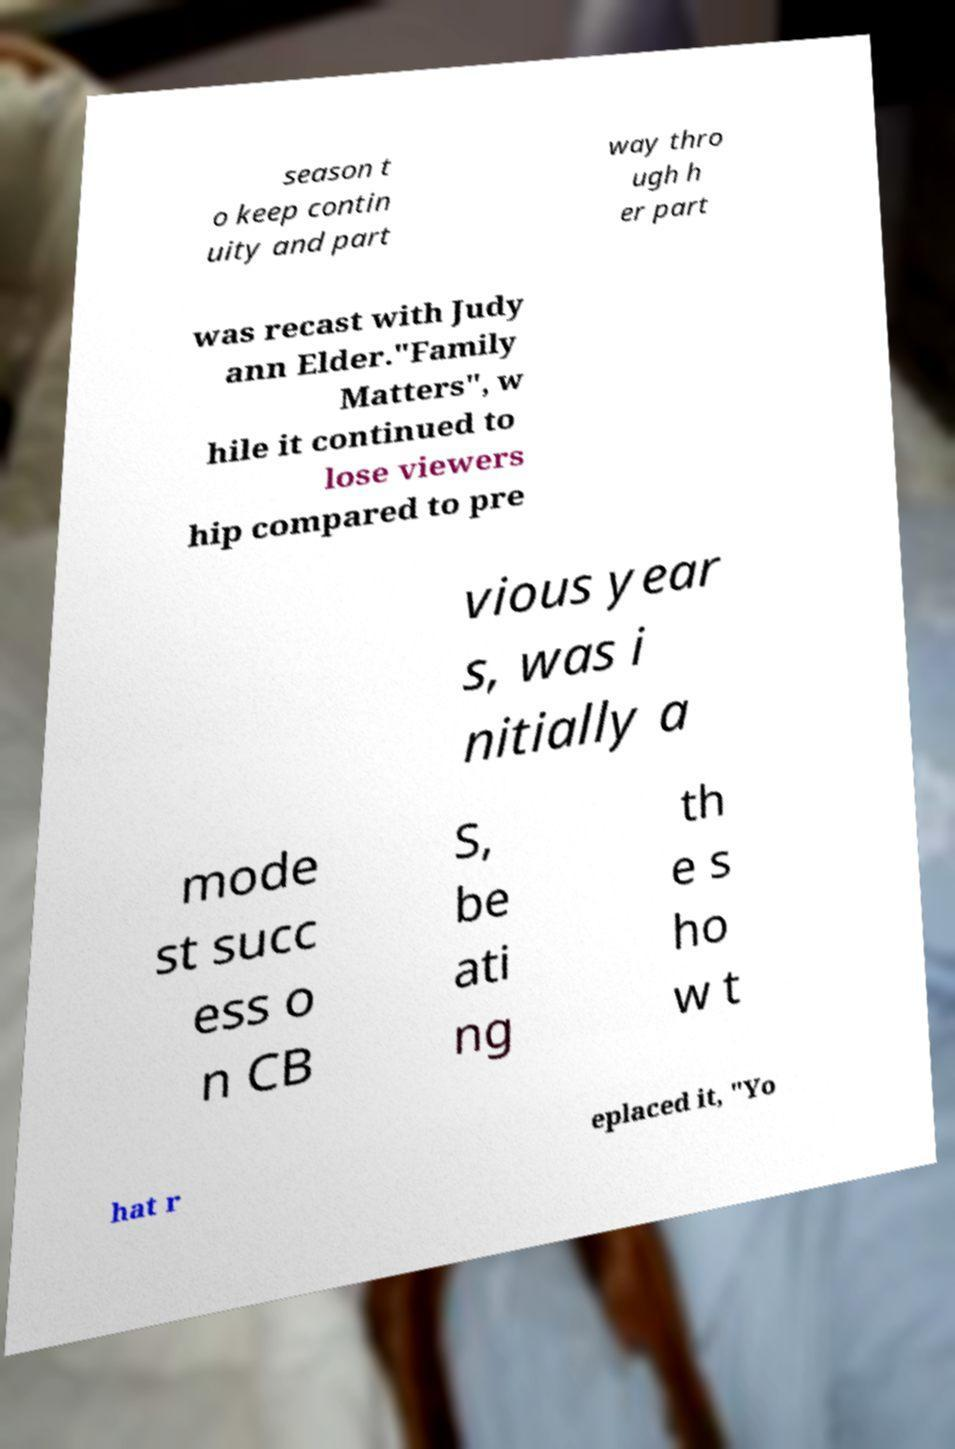Can you read and provide the text displayed in the image?This photo seems to have some interesting text. Can you extract and type it out for me? season t o keep contin uity and part way thro ugh h er part was recast with Judy ann Elder."Family Matters", w hile it continued to lose viewers hip compared to pre vious year s, was i nitially a mode st succ ess o n CB S, be ati ng th e s ho w t hat r eplaced it, "Yo 